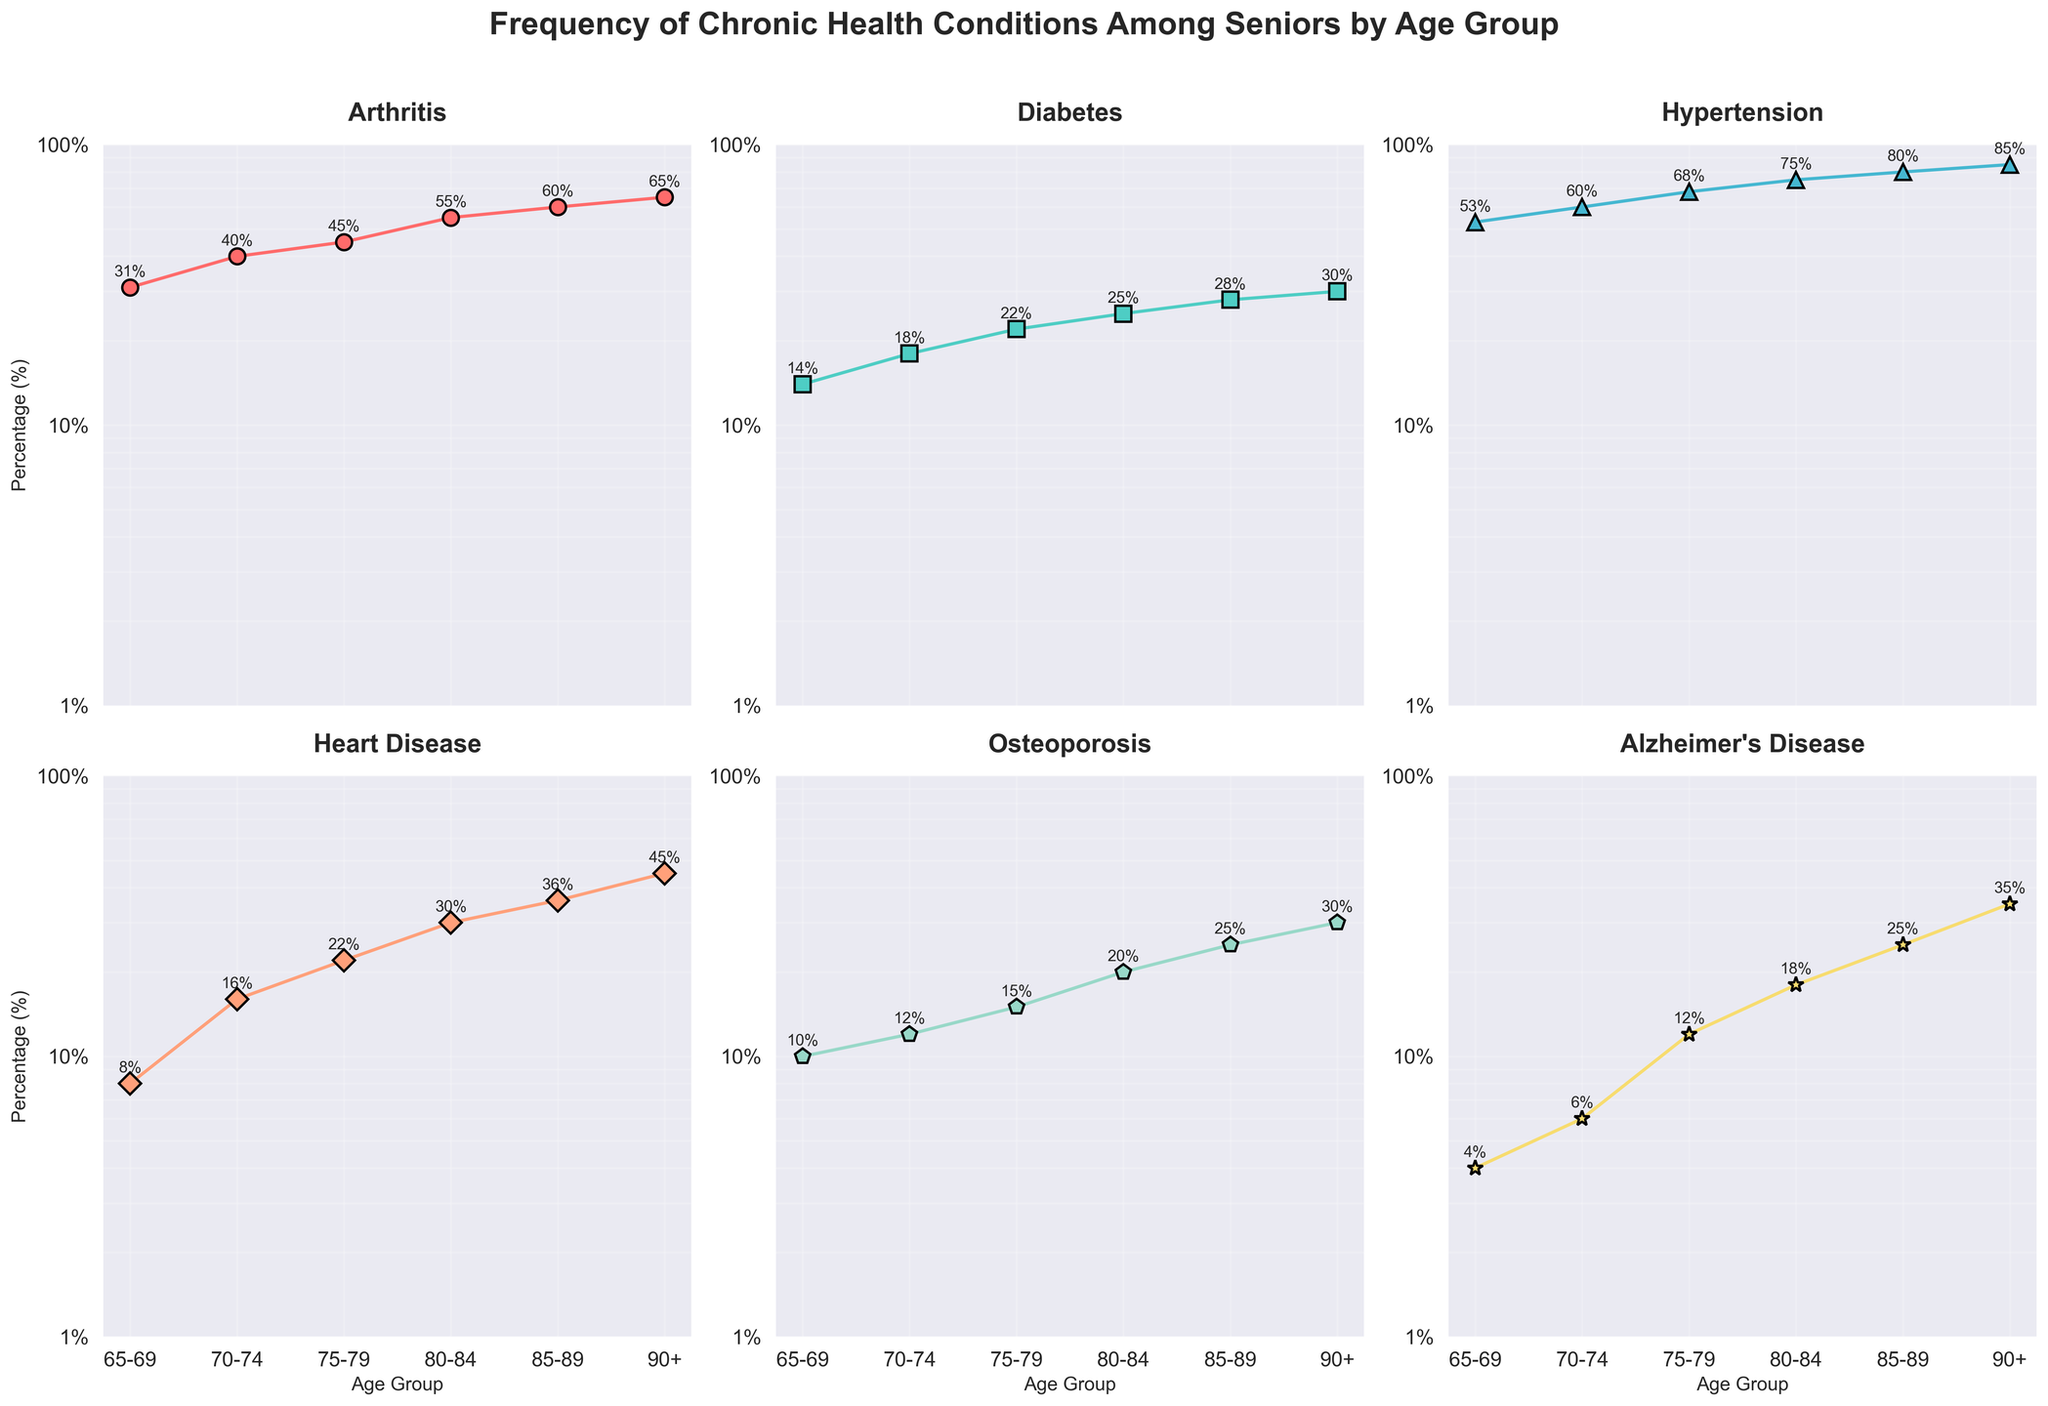What is the title of the plot? The title of the plot is usually located at the top center and provides an overview of the content. From the placement and size of the text, we can determine the title.
Answer: Frequency of Chronic Health Conditions Among Seniors by Age Group Which chronic condition has the highest percentage among the 90+ age group? We look at the values plotted for each condition in the 90+ age group and select the highest one. From the annotated values on the figure, it is evident.
Answer: Hypertension What is the approximate percentage of seniors aged 75-79 with Arthritis? We refer to the subplot titled "Arthritis" and locate the marker corresponding to the age group 75-79. According to the annotations, the percentage is given.
Answer: 45% How do the percentages of Diabetes change from age group 70-74 to 85-89? Locate the Diabetes subplot, and observe the annotated values for age groups 70-74 and 85-89. Calculate the difference between these values.
Answer: From 18% to 28% Which condition shows the largest increase in percentage from the 65-69 age group to the 90+ age group? Look at the starting and ending percentages for each condition across these age groups. Calculate the increase for each condition and identify the one with the highest increase.
Answer: Alzheimer's Disease Compare the percentages of Heart Disease and Osteoporosis in the age group 80-84. Which one is higher and by how much? Refer to the subplots for Heart Disease and Osteoporosis, find the annotations for the age group 80-84, and subtract the smaller value from the larger value.
Answer: Heart Disease by 10% At what age group does Hypertension exceed 70%? In the Hypertension subplot, identify the first age group with a percentage above 70% based on the annotations.
Answer: 75-79 Is there any condition that does not reach at least 50% in any age group? Check each subplot to see if any condition’s percentage remains below 50% in all age groups.
Answer: Yes, Diabetes What is the percentage difference of Alzheimer's Disease between the age groups 70-74 and 90+? Locate the Alzheimer's Disease subplot, find the values for the age groups 70-74 and 90+, and calculate the difference between these values.
Answer: 29% (35%-6%) How does the prevalence of Osteoporosis change for each subsequent age group? Refer to the Osteoporosis subplot, and compare the annotated values for each consecutive age group, noting the trend (increasing or stable).
Answer: Increases steadily 